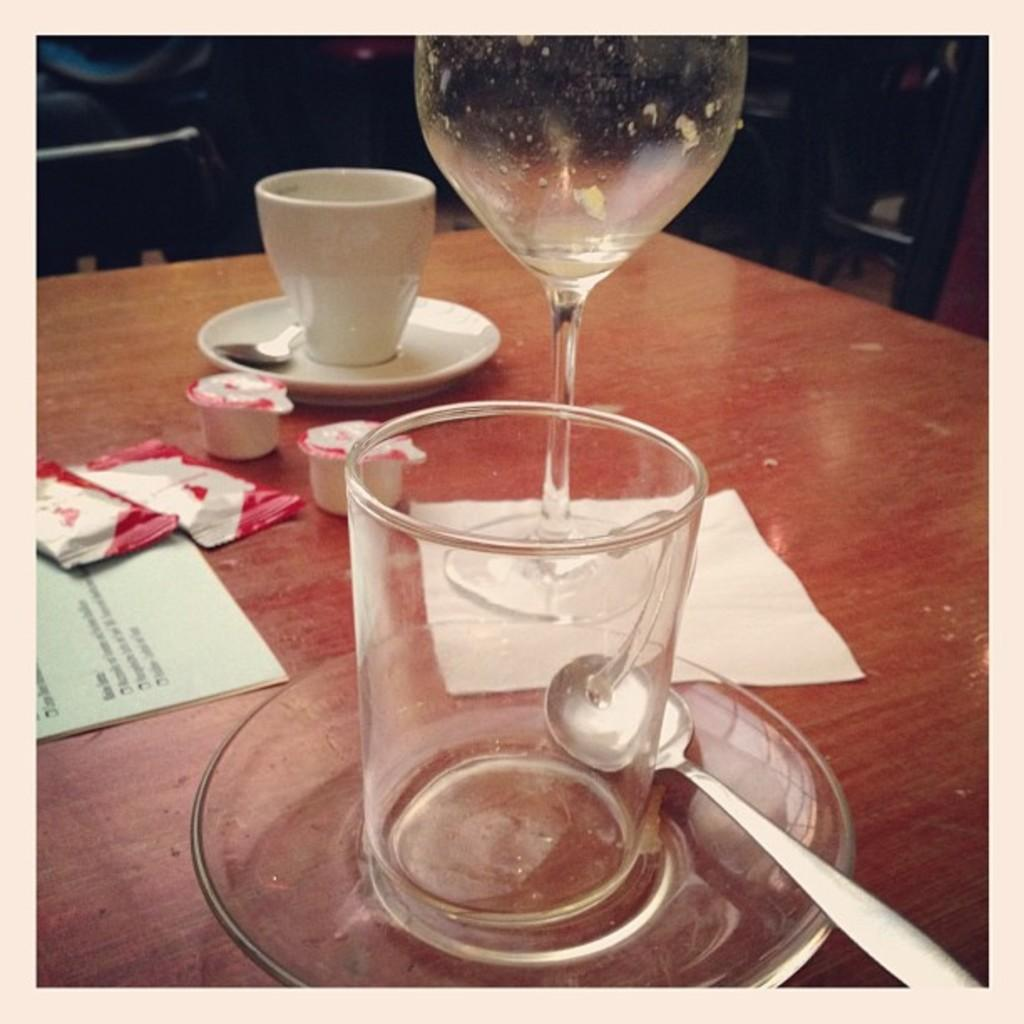What type of furniture is in the image? There is a table in the image. What items are on the table that are used for eating? Cutlery is present on the table. What items are on the table that are used for serving food? Crockery is present on the table. What type of items are on the table that are not related to eating or serving food? Papers are on the table. What type of food is visible on the table? Frozen food is visible on the table. Can you see a cow grazing on the table in the image? No, there is no cow present in the image. What type of brush is used to apply cream on the table in the image? There is no brush or cream present in the image. 